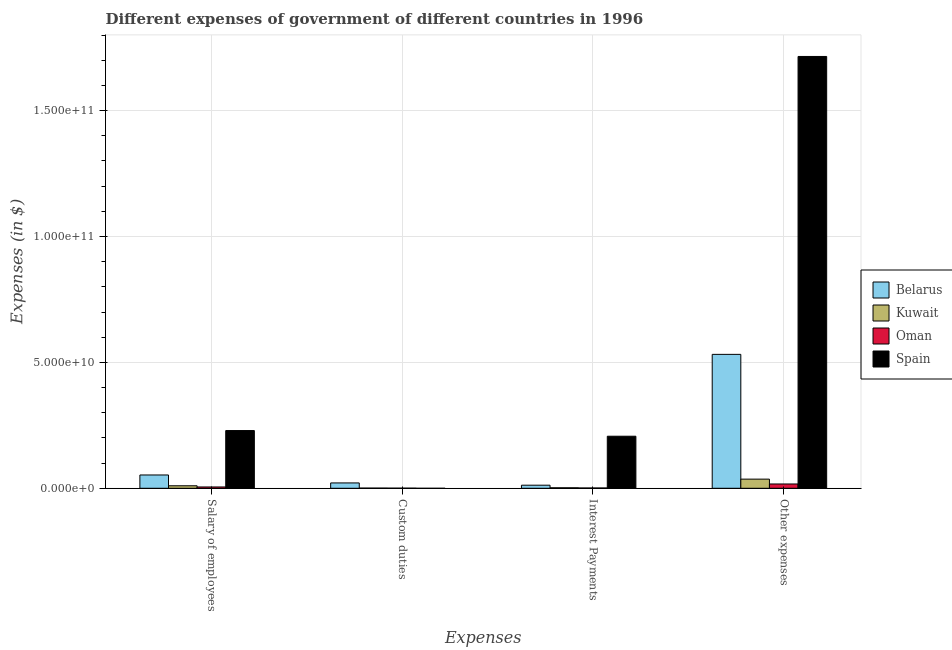How many groups of bars are there?
Keep it short and to the point. 4. Are the number of bars per tick equal to the number of legend labels?
Offer a terse response. No. How many bars are there on the 1st tick from the right?
Your response must be concise. 4. What is the label of the 4th group of bars from the left?
Offer a terse response. Other expenses. What is the amount spent on salary of employees in Spain?
Your answer should be very brief. 2.29e+1. Across all countries, what is the maximum amount spent on custom duties?
Provide a short and direct response. 2.12e+09. Across all countries, what is the minimum amount spent on salary of employees?
Make the answer very short. 5.22e+08. In which country was the amount spent on other expenses maximum?
Your answer should be compact. Spain. What is the total amount spent on custom duties in the graph?
Your answer should be very brief. 2.24e+09. What is the difference between the amount spent on other expenses in Oman and that in Belarus?
Make the answer very short. -5.15e+1. What is the difference between the amount spent on custom duties in Oman and the amount spent on salary of employees in Belarus?
Offer a terse response. -5.23e+09. What is the average amount spent on salary of employees per country?
Your answer should be very brief. 7.43e+09. What is the difference between the amount spent on salary of employees and amount spent on custom duties in Kuwait?
Your answer should be compact. 9.21e+08. What is the ratio of the amount spent on other expenses in Kuwait to that in Spain?
Give a very brief answer. 0.02. What is the difference between the highest and the second highest amount spent on interest payments?
Ensure brevity in your answer.  1.94e+1. What is the difference between the highest and the lowest amount spent on other expenses?
Offer a very short reply. 1.70e+11. In how many countries, is the amount spent on custom duties greater than the average amount spent on custom duties taken over all countries?
Your answer should be very brief. 1. Is the sum of the amount spent on salary of employees in Belarus and Spain greater than the maximum amount spent on other expenses across all countries?
Provide a succinct answer. No. Is it the case that in every country, the sum of the amount spent on salary of employees and amount spent on custom duties is greater than the amount spent on interest payments?
Make the answer very short. Yes. How many bars are there?
Make the answer very short. 15. How many countries are there in the graph?
Your answer should be very brief. 4. Does the graph contain any zero values?
Ensure brevity in your answer.  Yes. How are the legend labels stacked?
Offer a terse response. Vertical. What is the title of the graph?
Your response must be concise. Different expenses of government of different countries in 1996. Does "Sri Lanka" appear as one of the legend labels in the graph?
Ensure brevity in your answer.  No. What is the label or title of the X-axis?
Keep it short and to the point. Expenses. What is the label or title of the Y-axis?
Your answer should be very brief. Expenses (in $). What is the Expenses (in $) of Belarus in Salary of employees?
Offer a terse response. 5.28e+09. What is the Expenses (in $) in Kuwait in Salary of employees?
Make the answer very short. 9.93e+08. What is the Expenses (in $) in Oman in Salary of employees?
Give a very brief answer. 5.22e+08. What is the Expenses (in $) of Spain in Salary of employees?
Your response must be concise. 2.29e+1. What is the Expenses (in $) of Belarus in Custom duties?
Offer a very short reply. 2.12e+09. What is the Expenses (in $) in Kuwait in Custom duties?
Your answer should be very brief. 7.20e+07. What is the Expenses (in $) of Oman in Custom duties?
Ensure brevity in your answer.  4.76e+07. What is the Expenses (in $) of Belarus in Interest Payments?
Provide a short and direct response. 1.23e+09. What is the Expenses (in $) of Oman in Interest Payments?
Offer a terse response. 1.21e+08. What is the Expenses (in $) in Spain in Interest Payments?
Give a very brief answer. 2.07e+1. What is the Expenses (in $) in Belarus in Other expenses?
Offer a very short reply. 5.32e+1. What is the Expenses (in $) in Kuwait in Other expenses?
Your response must be concise. 3.63e+09. What is the Expenses (in $) of Oman in Other expenses?
Provide a short and direct response. 1.71e+09. What is the Expenses (in $) of Spain in Other expenses?
Your answer should be very brief. 1.71e+11. Across all Expenses, what is the maximum Expenses (in $) of Belarus?
Offer a very short reply. 5.32e+1. Across all Expenses, what is the maximum Expenses (in $) of Kuwait?
Make the answer very short. 3.63e+09. Across all Expenses, what is the maximum Expenses (in $) of Oman?
Your response must be concise. 1.71e+09. Across all Expenses, what is the maximum Expenses (in $) in Spain?
Offer a very short reply. 1.71e+11. Across all Expenses, what is the minimum Expenses (in $) in Belarus?
Your response must be concise. 1.23e+09. Across all Expenses, what is the minimum Expenses (in $) in Kuwait?
Your answer should be compact. 7.20e+07. Across all Expenses, what is the minimum Expenses (in $) in Oman?
Provide a short and direct response. 4.76e+07. Across all Expenses, what is the minimum Expenses (in $) in Spain?
Provide a short and direct response. 0. What is the total Expenses (in $) in Belarus in the graph?
Keep it short and to the point. 6.18e+1. What is the total Expenses (in $) of Kuwait in the graph?
Your answer should be compact. 4.90e+09. What is the total Expenses (in $) of Oman in the graph?
Give a very brief answer. 2.40e+09. What is the total Expenses (in $) in Spain in the graph?
Offer a terse response. 2.15e+11. What is the difference between the Expenses (in $) in Belarus in Salary of employees and that in Custom duties?
Ensure brevity in your answer.  3.16e+09. What is the difference between the Expenses (in $) of Kuwait in Salary of employees and that in Custom duties?
Your response must be concise. 9.21e+08. What is the difference between the Expenses (in $) of Oman in Salary of employees and that in Custom duties?
Offer a terse response. 4.74e+08. What is the difference between the Expenses (in $) of Belarus in Salary of employees and that in Interest Payments?
Offer a terse response. 4.06e+09. What is the difference between the Expenses (in $) in Kuwait in Salary of employees and that in Interest Payments?
Your answer should be compact. 7.93e+08. What is the difference between the Expenses (in $) of Oman in Salary of employees and that in Interest Payments?
Make the answer very short. 4.01e+08. What is the difference between the Expenses (in $) in Spain in Salary of employees and that in Interest Payments?
Keep it short and to the point. 2.25e+09. What is the difference between the Expenses (in $) in Belarus in Salary of employees and that in Other expenses?
Ensure brevity in your answer.  -4.79e+1. What is the difference between the Expenses (in $) of Kuwait in Salary of employees and that in Other expenses?
Keep it short and to the point. -2.64e+09. What is the difference between the Expenses (in $) in Oman in Salary of employees and that in Other expenses?
Ensure brevity in your answer.  -1.18e+09. What is the difference between the Expenses (in $) in Spain in Salary of employees and that in Other expenses?
Provide a short and direct response. -1.49e+11. What is the difference between the Expenses (in $) of Belarus in Custom duties and that in Interest Payments?
Ensure brevity in your answer.  8.98e+08. What is the difference between the Expenses (in $) in Kuwait in Custom duties and that in Interest Payments?
Your answer should be very brief. -1.28e+08. What is the difference between the Expenses (in $) in Oman in Custom duties and that in Interest Payments?
Offer a terse response. -7.36e+07. What is the difference between the Expenses (in $) in Belarus in Custom duties and that in Other expenses?
Provide a short and direct response. -5.11e+1. What is the difference between the Expenses (in $) in Kuwait in Custom duties and that in Other expenses?
Provide a short and direct response. -3.56e+09. What is the difference between the Expenses (in $) of Oman in Custom duties and that in Other expenses?
Ensure brevity in your answer.  -1.66e+09. What is the difference between the Expenses (in $) of Belarus in Interest Payments and that in Other expenses?
Your answer should be compact. -5.20e+1. What is the difference between the Expenses (in $) of Kuwait in Interest Payments and that in Other expenses?
Give a very brief answer. -3.43e+09. What is the difference between the Expenses (in $) in Oman in Interest Payments and that in Other expenses?
Your response must be concise. -1.59e+09. What is the difference between the Expenses (in $) in Spain in Interest Payments and that in Other expenses?
Provide a succinct answer. -1.51e+11. What is the difference between the Expenses (in $) of Belarus in Salary of employees and the Expenses (in $) of Kuwait in Custom duties?
Ensure brevity in your answer.  5.21e+09. What is the difference between the Expenses (in $) in Belarus in Salary of employees and the Expenses (in $) in Oman in Custom duties?
Provide a succinct answer. 5.23e+09. What is the difference between the Expenses (in $) in Kuwait in Salary of employees and the Expenses (in $) in Oman in Custom duties?
Provide a short and direct response. 9.45e+08. What is the difference between the Expenses (in $) in Belarus in Salary of employees and the Expenses (in $) in Kuwait in Interest Payments?
Your response must be concise. 5.08e+09. What is the difference between the Expenses (in $) of Belarus in Salary of employees and the Expenses (in $) of Oman in Interest Payments?
Provide a succinct answer. 5.16e+09. What is the difference between the Expenses (in $) in Belarus in Salary of employees and the Expenses (in $) in Spain in Interest Payments?
Make the answer very short. -1.54e+1. What is the difference between the Expenses (in $) in Kuwait in Salary of employees and the Expenses (in $) in Oman in Interest Payments?
Keep it short and to the point. 8.72e+08. What is the difference between the Expenses (in $) in Kuwait in Salary of employees and the Expenses (in $) in Spain in Interest Payments?
Offer a terse response. -1.97e+1. What is the difference between the Expenses (in $) of Oman in Salary of employees and the Expenses (in $) of Spain in Interest Payments?
Make the answer very short. -2.02e+1. What is the difference between the Expenses (in $) of Belarus in Salary of employees and the Expenses (in $) of Kuwait in Other expenses?
Provide a short and direct response. 1.65e+09. What is the difference between the Expenses (in $) in Belarus in Salary of employees and the Expenses (in $) in Oman in Other expenses?
Your response must be concise. 3.58e+09. What is the difference between the Expenses (in $) in Belarus in Salary of employees and the Expenses (in $) in Spain in Other expenses?
Your answer should be compact. -1.66e+11. What is the difference between the Expenses (in $) of Kuwait in Salary of employees and the Expenses (in $) of Oman in Other expenses?
Offer a very short reply. -7.13e+08. What is the difference between the Expenses (in $) in Kuwait in Salary of employees and the Expenses (in $) in Spain in Other expenses?
Ensure brevity in your answer.  -1.71e+11. What is the difference between the Expenses (in $) of Oman in Salary of employees and the Expenses (in $) of Spain in Other expenses?
Your answer should be compact. -1.71e+11. What is the difference between the Expenses (in $) of Belarus in Custom duties and the Expenses (in $) of Kuwait in Interest Payments?
Offer a terse response. 1.92e+09. What is the difference between the Expenses (in $) of Belarus in Custom duties and the Expenses (in $) of Oman in Interest Payments?
Offer a terse response. 2.00e+09. What is the difference between the Expenses (in $) in Belarus in Custom duties and the Expenses (in $) in Spain in Interest Payments?
Your answer should be very brief. -1.85e+1. What is the difference between the Expenses (in $) of Kuwait in Custom duties and the Expenses (in $) of Oman in Interest Payments?
Make the answer very short. -4.92e+07. What is the difference between the Expenses (in $) in Kuwait in Custom duties and the Expenses (in $) in Spain in Interest Payments?
Keep it short and to the point. -2.06e+1. What is the difference between the Expenses (in $) of Oman in Custom duties and the Expenses (in $) of Spain in Interest Payments?
Make the answer very short. -2.06e+1. What is the difference between the Expenses (in $) in Belarus in Custom duties and the Expenses (in $) in Kuwait in Other expenses?
Provide a short and direct response. -1.51e+09. What is the difference between the Expenses (in $) of Belarus in Custom duties and the Expenses (in $) of Oman in Other expenses?
Provide a succinct answer. 4.18e+08. What is the difference between the Expenses (in $) of Belarus in Custom duties and the Expenses (in $) of Spain in Other expenses?
Keep it short and to the point. -1.69e+11. What is the difference between the Expenses (in $) in Kuwait in Custom duties and the Expenses (in $) in Oman in Other expenses?
Your response must be concise. -1.63e+09. What is the difference between the Expenses (in $) in Kuwait in Custom duties and the Expenses (in $) in Spain in Other expenses?
Your response must be concise. -1.71e+11. What is the difference between the Expenses (in $) in Oman in Custom duties and the Expenses (in $) in Spain in Other expenses?
Your response must be concise. -1.71e+11. What is the difference between the Expenses (in $) of Belarus in Interest Payments and the Expenses (in $) of Kuwait in Other expenses?
Keep it short and to the point. -2.40e+09. What is the difference between the Expenses (in $) in Belarus in Interest Payments and the Expenses (in $) in Oman in Other expenses?
Offer a terse response. -4.80e+08. What is the difference between the Expenses (in $) of Belarus in Interest Payments and the Expenses (in $) of Spain in Other expenses?
Keep it short and to the point. -1.70e+11. What is the difference between the Expenses (in $) of Kuwait in Interest Payments and the Expenses (in $) of Oman in Other expenses?
Make the answer very short. -1.51e+09. What is the difference between the Expenses (in $) of Kuwait in Interest Payments and the Expenses (in $) of Spain in Other expenses?
Offer a very short reply. -1.71e+11. What is the difference between the Expenses (in $) of Oman in Interest Payments and the Expenses (in $) of Spain in Other expenses?
Provide a succinct answer. -1.71e+11. What is the average Expenses (in $) of Belarus per Expenses?
Your answer should be very brief. 1.55e+1. What is the average Expenses (in $) of Kuwait per Expenses?
Keep it short and to the point. 1.22e+09. What is the average Expenses (in $) of Oman per Expenses?
Give a very brief answer. 5.99e+08. What is the average Expenses (in $) of Spain per Expenses?
Offer a very short reply. 5.38e+1. What is the difference between the Expenses (in $) in Belarus and Expenses (in $) in Kuwait in Salary of employees?
Offer a very short reply. 4.29e+09. What is the difference between the Expenses (in $) in Belarus and Expenses (in $) in Oman in Salary of employees?
Your answer should be compact. 4.76e+09. What is the difference between the Expenses (in $) in Belarus and Expenses (in $) in Spain in Salary of employees?
Give a very brief answer. -1.76e+1. What is the difference between the Expenses (in $) of Kuwait and Expenses (in $) of Oman in Salary of employees?
Ensure brevity in your answer.  4.71e+08. What is the difference between the Expenses (in $) in Kuwait and Expenses (in $) in Spain in Salary of employees?
Your response must be concise. -2.19e+1. What is the difference between the Expenses (in $) of Oman and Expenses (in $) of Spain in Salary of employees?
Your answer should be very brief. -2.24e+1. What is the difference between the Expenses (in $) of Belarus and Expenses (in $) of Kuwait in Custom duties?
Provide a short and direct response. 2.05e+09. What is the difference between the Expenses (in $) in Belarus and Expenses (in $) in Oman in Custom duties?
Provide a short and direct response. 2.08e+09. What is the difference between the Expenses (in $) in Kuwait and Expenses (in $) in Oman in Custom duties?
Offer a terse response. 2.44e+07. What is the difference between the Expenses (in $) in Belarus and Expenses (in $) in Kuwait in Interest Payments?
Ensure brevity in your answer.  1.03e+09. What is the difference between the Expenses (in $) of Belarus and Expenses (in $) of Oman in Interest Payments?
Offer a very short reply. 1.11e+09. What is the difference between the Expenses (in $) of Belarus and Expenses (in $) of Spain in Interest Payments?
Keep it short and to the point. -1.94e+1. What is the difference between the Expenses (in $) in Kuwait and Expenses (in $) in Oman in Interest Payments?
Provide a succinct answer. 7.88e+07. What is the difference between the Expenses (in $) in Kuwait and Expenses (in $) in Spain in Interest Payments?
Your response must be concise. -2.05e+1. What is the difference between the Expenses (in $) of Oman and Expenses (in $) of Spain in Interest Payments?
Offer a terse response. -2.06e+1. What is the difference between the Expenses (in $) of Belarus and Expenses (in $) of Kuwait in Other expenses?
Your answer should be very brief. 4.96e+1. What is the difference between the Expenses (in $) in Belarus and Expenses (in $) in Oman in Other expenses?
Your answer should be very brief. 5.15e+1. What is the difference between the Expenses (in $) of Belarus and Expenses (in $) of Spain in Other expenses?
Your answer should be compact. -1.18e+11. What is the difference between the Expenses (in $) of Kuwait and Expenses (in $) of Oman in Other expenses?
Make the answer very short. 1.92e+09. What is the difference between the Expenses (in $) of Kuwait and Expenses (in $) of Spain in Other expenses?
Your response must be concise. -1.68e+11. What is the difference between the Expenses (in $) in Oman and Expenses (in $) in Spain in Other expenses?
Your response must be concise. -1.70e+11. What is the ratio of the Expenses (in $) in Belarus in Salary of employees to that in Custom duties?
Offer a terse response. 2.49. What is the ratio of the Expenses (in $) of Kuwait in Salary of employees to that in Custom duties?
Your response must be concise. 13.79. What is the ratio of the Expenses (in $) in Oman in Salary of employees to that in Custom duties?
Provide a succinct answer. 10.96. What is the ratio of the Expenses (in $) of Belarus in Salary of employees to that in Interest Payments?
Give a very brief answer. 4.31. What is the ratio of the Expenses (in $) of Kuwait in Salary of employees to that in Interest Payments?
Your answer should be compact. 4.96. What is the ratio of the Expenses (in $) in Oman in Salary of employees to that in Interest Payments?
Offer a terse response. 4.31. What is the ratio of the Expenses (in $) in Spain in Salary of employees to that in Interest Payments?
Your answer should be very brief. 1.11. What is the ratio of the Expenses (in $) of Belarus in Salary of employees to that in Other expenses?
Keep it short and to the point. 0.1. What is the ratio of the Expenses (in $) of Kuwait in Salary of employees to that in Other expenses?
Offer a terse response. 0.27. What is the ratio of the Expenses (in $) of Oman in Salary of employees to that in Other expenses?
Your answer should be compact. 0.31. What is the ratio of the Expenses (in $) in Spain in Salary of employees to that in Other expenses?
Offer a very short reply. 0.13. What is the ratio of the Expenses (in $) of Belarus in Custom duties to that in Interest Payments?
Your answer should be very brief. 1.73. What is the ratio of the Expenses (in $) in Kuwait in Custom duties to that in Interest Payments?
Make the answer very short. 0.36. What is the ratio of the Expenses (in $) in Oman in Custom duties to that in Interest Payments?
Make the answer very short. 0.39. What is the ratio of the Expenses (in $) in Belarus in Custom duties to that in Other expenses?
Make the answer very short. 0.04. What is the ratio of the Expenses (in $) in Kuwait in Custom duties to that in Other expenses?
Make the answer very short. 0.02. What is the ratio of the Expenses (in $) of Oman in Custom duties to that in Other expenses?
Provide a short and direct response. 0.03. What is the ratio of the Expenses (in $) in Belarus in Interest Payments to that in Other expenses?
Provide a short and direct response. 0.02. What is the ratio of the Expenses (in $) of Kuwait in Interest Payments to that in Other expenses?
Your answer should be compact. 0.06. What is the ratio of the Expenses (in $) of Oman in Interest Payments to that in Other expenses?
Provide a succinct answer. 0.07. What is the ratio of the Expenses (in $) of Spain in Interest Payments to that in Other expenses?
Offer a very short reply. 0.12. What is the difference between the highest and the second highest Expenses (in $) in Belarus?
Give a very brief answer. 4.79e+1. What is the difference between the highest and the second highest Expenses (in $) of Kuwait?
Offer a terse response. 2.64e+09. What is the difference between the highest and the second highest Expenses (in $) of Oman?
Ensure brevity in your answer.  1.18e+09. What is the difference between the highest and the second highest Expenses (in $) in Spain?
Your answer should be compact. 1.49e+11. What is the difference between the highest and the lowest Expenses (in $) of Belarus?
Provide a short and direct response. 5.20e+1. What is the difference between the highest and the lowest Expenses (in $) in Kuwait?
Offer a very short reply. 3.56e+09. What is the difference between the highest and the lowest Expenses (in $) in Oman?
Keep it short and to the point. 1.66e+09. What is the difference between the highest and the lowest Expenses (in $) in Spain?
Provide a short and direct response. 1.71e+11. 